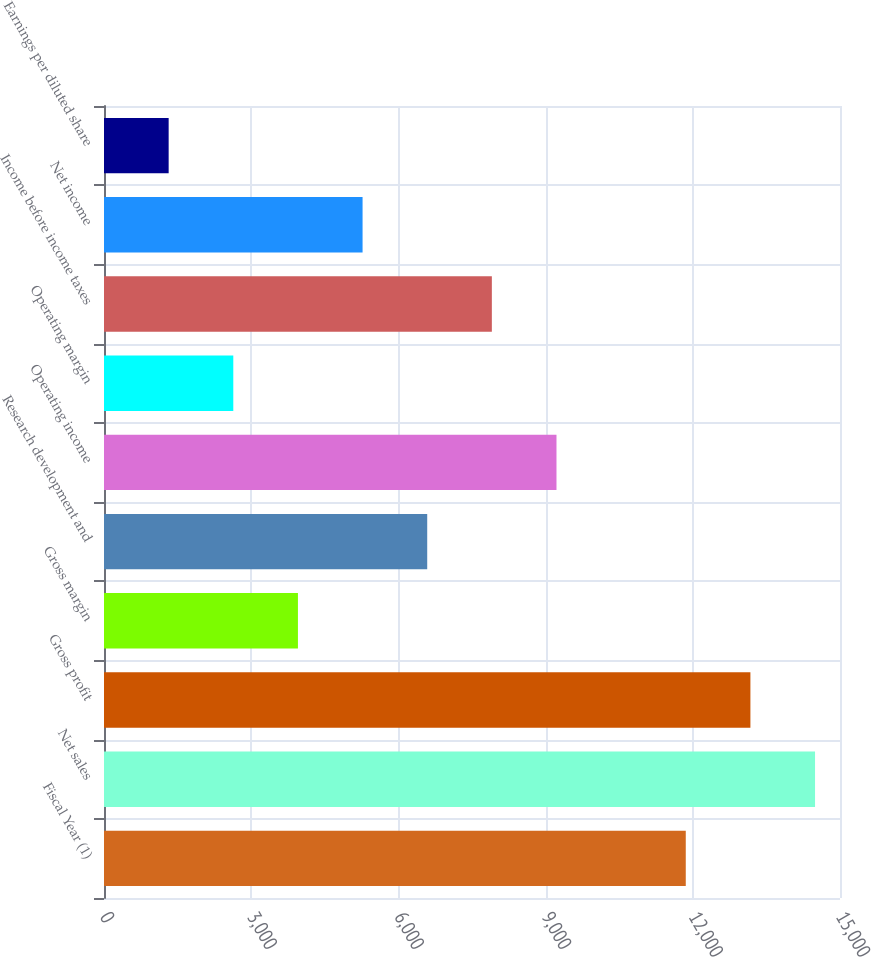<chart> <loc_0><loc_0><loc_500><loc_500><bar_chart><fcel>Fiscal Year (1)<fcel>Net sales<fcel>Gross profit<fcel>Gross margin<fcel>Research development and<fcel>Operating income<fcel>Operating margin<fcel>Income before income taxes<fcel>Net income<fcel>Earnings per diluted share<nl><fcel>11856.6<fcel>14491.4<fcel>13174<fcel>3952.48<fcel>6587.2<fcel>9221.92<fcel>2635.12<fcel>7904.56<fcel>5269.84<fcel>1317.76<nl></chart> 